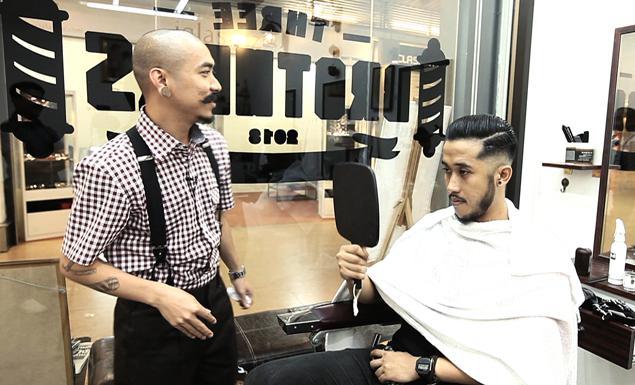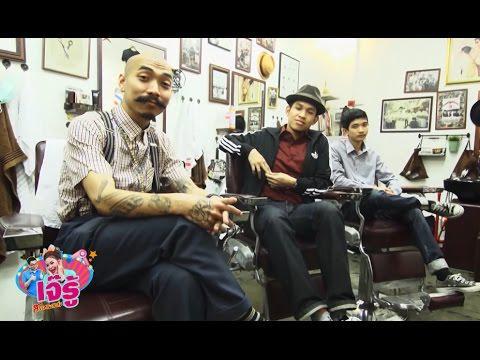The first image is the image on the left, the second image is the image on the right. Evaluate the accuracy of this statement regarding the images: "Three men are sitting in barber chairs in one of the images.". Is it true? Answer yes or no. Yes. The first image is the image on the left, the second image is the image on the right. For the images shown, is this caption "In one image three men are sitting in barber chairs, one of them bald, one wearing a hat, and one with hair and no hat." true? Answer yes or no. Yes. 